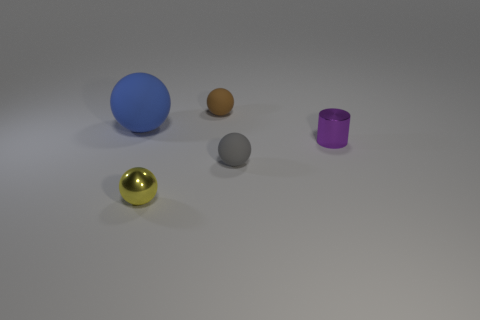Subtract all small balls. How many balls are left? 1 Subtract all gray spheres. How many spheres are left? 3 Subtract 1 cylinders. How many cylinders are left? 0 Subtract all gray spheres. How many gray cylinders are left? 0 Add 3 purple metal objects. How many purple metal objects are left? 4 Add 5 blue spheres. How many blue spheres exist? 6 Add 3 gray things. How many objects exist? 8 Subtract 1 gray balls. How many objects are left? 4 Subtract all cylinders. How many objects are left? 4 Subtract all red cylinders. Subtract all yellow spheres. How many cylinders are left? 1 